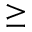Convert formula to latex. <formula><loc_0><loc_0><loc_500><loc_500>\geq</formula> 